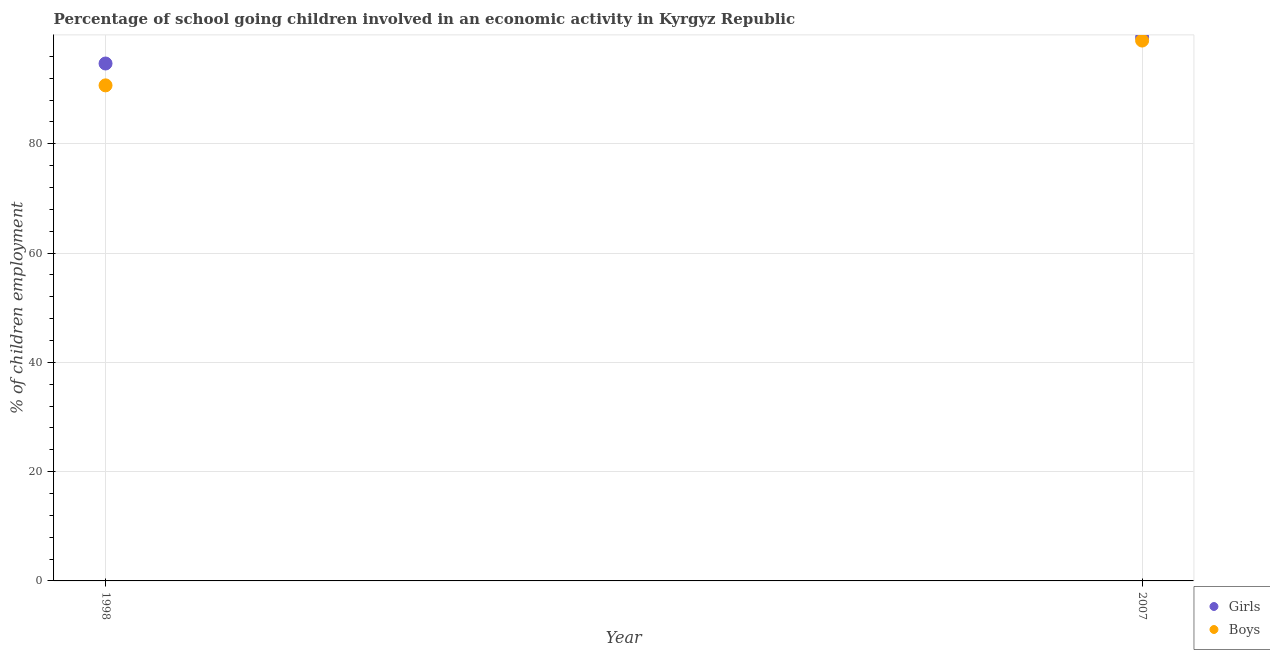How many different coloured dotlines are there?
Give a very brief answer. 2. Is the number of dotlines equal to the number of legend labels?
Provide a succinct answer. Yes. What is the percentage of school going girls in 1998?
Your response must be concise. 94.7. Across all years, what is the maximum percentage of school going boys?
Keep it short and to the point. 98.9. Across all years, what is the minimum percentage of school going boys?
Offer a very short reply. 90.7. In which year was the percentage of school going girls maximum?
Ensure brevity in your answer.  2007. What is the total percentage of school going girls in the graph?
Give a very brief answer. 194.2. What is the difference between the percentage of school going girls in 1998 and that in 2007?
Keep it short and to the point. -4.8. What is the difference between the percentage of school going boys in 2007 and the percentage of school going girls in 1998?
Offer a terse response. 4.2. What is the average percentage of school going girls per year?
Keep it short and to the point. 97.1. In the year 1998, what is the difference between the percentage of school going boys and percentage of school going girls?
Provide a succinct answer. -4. What is the ratio of the percentage of school going girls in 1998 to that in 2007?
Your answer should be compact. 0.95. Is the percentage of school going girls in 1998 less than that in 2007?
Offer a terse response. Yes. Is the percentage of school going girls strictly greater than the percentage of school going boys over the years?
Your response must be concise. Yes. How many years are there in the graph?
Your answer should be very brief. 2. Are the values on the major ticks of Y-axis written in scientific E-notation?
Offer a terse response. No. Does the graph contain any zero values?
Ensure brevity in your answer.  No. Does the graph contain grids?
Offer a terse response. Yes. How many legend labels are there?
Give a very brief answer. 2. How are the legend labels stacked?
Your answer should be very brief. Vertical. What is the title of the graph?
Your response must be concise. Percentage of school going children involved in an economic activity in Kyrgyz Republic. Does "Merchandise imports" appear as one of the legend labels in the graph?
Provide a succinct answer. No. What is the label or title of the X-axis?
Give a very brief answer. Year. What is the label or title of the Y-axis?
Your response must be concise. % of children employment. What is the % of children employment of Girls in 1998?
Offer a very short reply. 94.7. What is the % of children employment in Boys in 1998?
Offer a terse response. 90.7. What is the % of children employment in Girls in 2007?
Offer a terse response. 99.5. What is the % of children employment in Boys in 2007?
Keep it short and to the point. 98.9. Across all years, what is the maximum % of children employment of Girls?
Provide a short and direct response. 99.5. Across all years, what is the maximum % of children employment of Boys?
Offer a terse response. 98.9. Across all years, what is the minimum % of children employment in Girls?
Offer a very short reply. 94.7. Across all years, what is the minimum % of children employment in Boys?
Your answer should be very brief. 90.7. What is the total % of children employment of Girls in the graph?
Provide a succinct answer. 194.2. What is the total % of children employment of Boys in the graph?
Keep it short and to the point. 189.6. What is the average % of children employment in Girls per year?
Your answer should be very brief. 97.1. What is the average % of children employment of Boys per year?
Keep it short and to the point. 94.8. In the year 1998, what is the difference between the % of children employment in Girls and % of children employment in Boys?
Your answer should be very brief. 4. What is the ratio of the % of children employment in Girls in 1998 to that in 2007?
Your response must be concise. 0.95. What is the ratio of the % of children employment of Boys in 1998 to that in 2007?
Your response must be concise. 0.92. What is the difference between the highest and the second highest % of children employment in Girls?
Your answer should be compact. 4.8. What is the difference between the highest and the lowest % of children employment of Boys?
Offer a very short reply. 8.2. 